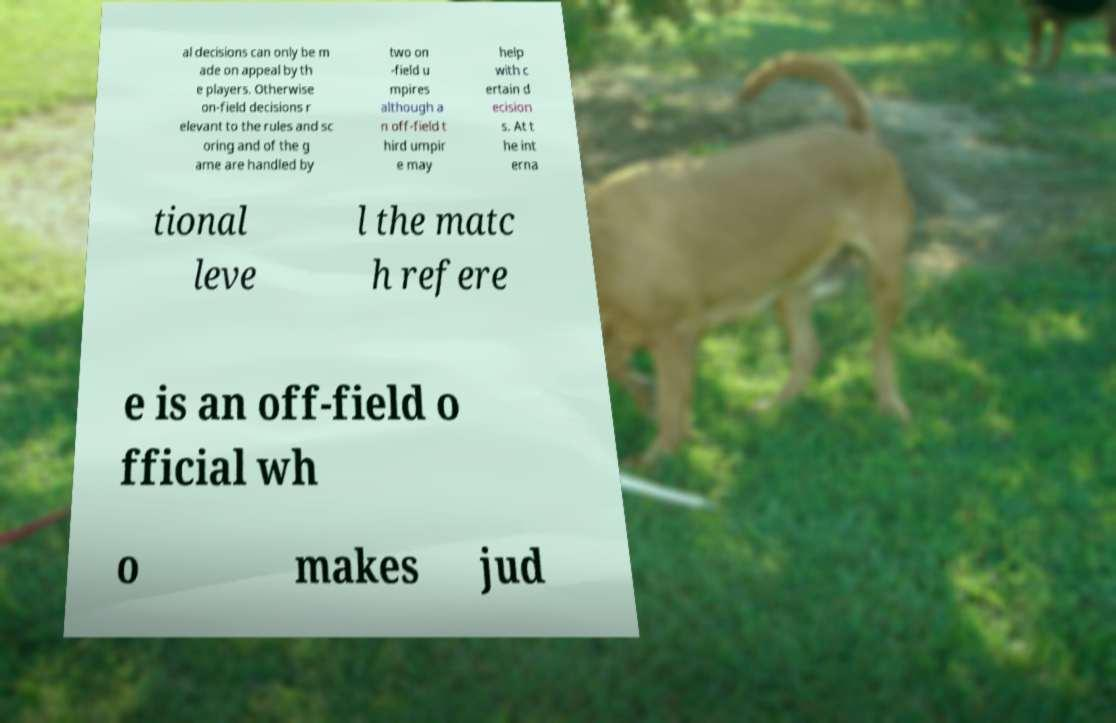Can you read and provide the text displayed in the image?This photo seems to have some interesting text. Can you extract and type it out for me? al decisions can only be m ade on appeal by th e players. Otherwise on-field decisions r elevant to the rules and sc oring and of the g ame are handled by two on -field u mpires although a n off-field t hird umpir e may help with c ertain d ecision s. At t he int erna tional leve l the matc h refere e is an off-field o fficial wh o makes jud 